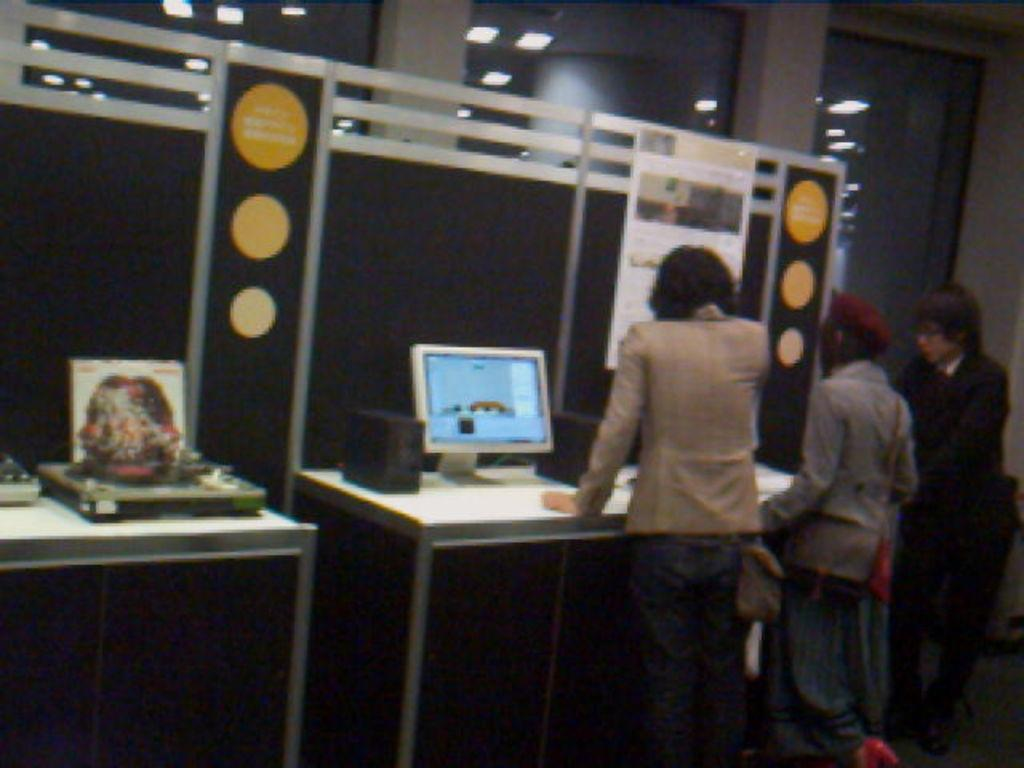What is happening in the image? There are people standing in the image. What object can be seen on the table? There is a monitor on the table. Can you describe the table in the image? The table is where the monitor is placed. What type of thumb is visible on the monitor in the image? There is no thumb visible on the monitor in the image. Can you describe the door in the image? There is no door present in the image. 